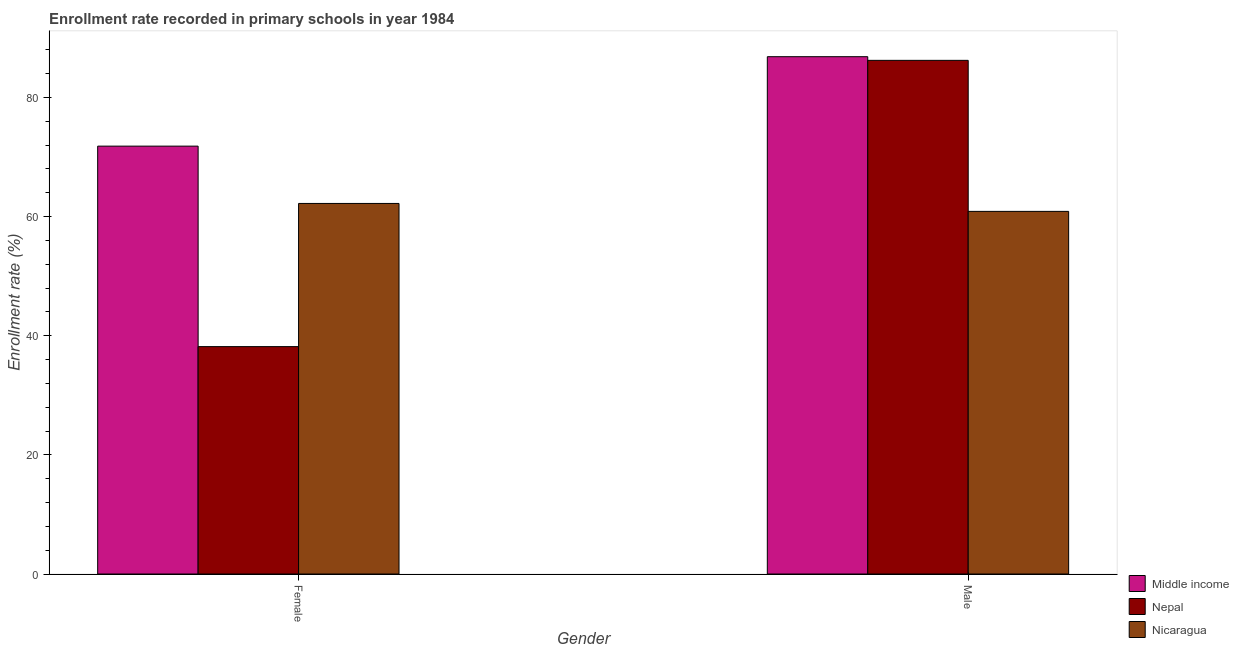How many different coloured bars are there?
Give a very brief answer. 3. Are the number of bars per tick equal to the number of legend labels?
Make the answer very short. Yes. How many bars are there on the 2nd tick from the left?
Offer a terse response. 3. How many bars are there on the 2nd tick from the right?
Provide a short and direct response. 3. What is the label of the 1st group of bars from the left?
Keep it short and to the point. Female. What is the enrollment rate of male students in Nicaragua?
Offer a terse response. 60.88. Across all countries, what is the maximum enrollment rate of female students?
Give a very brief answer. 71.84. Across all countries, what is the minimum enrollment rate of male students?
Provide a short and direct response. 60.88. In which country was the enrollment rate of female students maximum?
Your answer should be compact. Middle income. In which country was the enrollment rate of male students minimum?
Offer a terse response. Nicaragua. What is the total enrollment rate of female students in the graph?
Your response must be concise. 172.23. What is the difference between the enrollment rate of female students in Nepal and that in Nicaragua?
Provide a short and direct response. -24.04. What is the difference between the enrollment rate of male students in Middle income and the enrollment rate of female students in Nepal?
Offer a terse response. 48.68. What is the average enrollment rate of female students per country?
Provide a short and direct response. 57.41. What is the difference between the enrollment rate of female students and enrollment rate of male students in Middle income?
Provide a succinct answer. -15.02. What is the ratio of the enrollment rate of male students in Nepal to that in Nicaragua?
Give a very brief answer. 1.42. In how many countries, is the enrollment rate of male students greater than the average enrollment rate of male students taken over all countries?
Make the answer very short. 2. What does the 1st bar from the left in Female represents?
Keep it short and to the point. Middle income. What does the 2nd bar from the right in Male represents?
Offer a terse response. Nepal. Are all the bars in the graph horizontal?
Ensure brevity in your answer.  No. How many countries are there in the graph?
Make the answer very short. 3. Does the graph contain grids?
Your response must be concise. No. Where does the legend appear in the graph?
Offer a very short reply. Bottom right. What is the title of the graph?
Give a very brief answer. Enrollment rate recorded in primary schools in year 1984. What is the label or title of the X-axis?
Give a very brief answer. Gender. What is the label or title of the Y-axis?
Offer a very short reply. Enrollment rate (%). What is the Enrollment rate (%) in Middle income in Female?
Provide a short and direct response. 71.84. What is the Enrollment rate (%) of Nepal in Female?
Give a very brief answer. 38.18. What is the Enrollment rate (%) of Nicaragua in Female?
Keep it short and to the point. 62.22. What is the Enrollment rate (%) in Middle income in Male?
Your answer should be compact. 86.86. What is the Enrollment rate (%) of Nepal in Male?
Your response must be concise. 86.24. What is the Enrollment rate (%) in Nicaragua in Male?
Ensure brevity in your answer.  60.88. Across all Gender, what is the maximum Enrollment rate (%) in Middle income?
Your response must be concise. 86.86. Across all Gender, what is the maximum Enrollment rate (%) of Nepal?
Provide a succinct answer. 86.24. Across all Gender, what is the maximum Enrollment rate (%) of Nicaragua?
Your answer should be compact. 62.22. Across all Gender, what is the minimum Enrollment rate (%) of Middle income?
Your response must be concise. 71.84. Across all Gender, what is the minimum Enrollment rate (%) of Nepal?
Make the answer very short. 38.18. Across all Gender, what is the minimum Enrollment rate (%) of Nicaragua?
Your answer should be compact. 60.88. What is the total Enrollment rate (%) in Middle income in the graph?
Your answer should be very brief. 158.69. What is the total Enrollment rate (%) in Nepal in the graph?
Give a very brief answer. 124.42. What is the total Enrollment rate (%) of Nicaragua in the graph?
Keep it short and to the point. 123.1. What is the difference between the Enrollment rate (%) in Middle income in Female and that in Male?
Your answer should be compact. -15.02. What is the difference between the Enrollment rate (%) of Nepal in Female and that in Male?
Your answer should be very brief. -48.06. What is the difference between the Enrollment rate (%) in Nicaragua in Female and that in Male?
Your answer should be very brief. 1.33. What is the difference between the Enrollment rate (%) of Middle income in Female and the Enrollment rate (%) of Nepal in Male?
Give a very brief answer. -14.4. What is the difference between the Enrollment rate (%) in Middle income in Female and the Enrollment rate (%) in Nicaragua in Male?
Offer a very short reply. 10.95. What is the difference between the Enrollment rate (%) of Nepal in Female and the Enrollment rate (%) of Nicaragua in Male?
Give a very brief answer. -22.71. What is the average Enrollment rate (%) of Middle income per Gender?
Your answer should be very brief. 79.35. What is the average Enrollment rate (%) in Nepal per Gender?
Offer a very short reply. 62.21. What is the average Enrollment rate (%) in Nicaragua per Gender?
Give a very brief answer. 61.55. What is the difference between the Enrollment rate (%) in Middle income and Enrollment rate (%) in Nepal in Female?
Your answer should be compact. 33.66. What is the difference between the Enrollment rate (%) in Middle income and Enrollment rate (%) in Nicaragua in Female?
Keep it short and to the point. 9.62. What is the difference between the Enrollment rate (%) of Nepal and Enrollment rate (%) of Nicaragua in Female?
Ensure brevity in your answer.  -24.04. What is the difference between the Enrollment rate (%) in Middle income and Enrollment rate (%) in Nepal in Male?
Provide a short and direct response. 0.62. What is the difference between the Enrollment rate (%) in Middle income and Enrollment rate (%) in Nicaragua in Male?
Keep it short and to the point. 25.97. What is the difference between the Enrollment rate (%) in Nepal and Enrollment rate (%) in Nicaragua in Male?
Offer a terse response. 25.36. What is the ratio of the Enrollment rate (%) in Middle income in Female to that in Male?
Offer a very short reply. 0.83. What is the ratio of the Enrollment rate (%) of Nepal in Female to that in Male?
Offer a very short reply. 0.44. What is the ratio of the Enrollment rate (%) in Nicaragua in Female to that in Male?
Offer a very short reply. 1.02. What is the difference between the highest and the second highest Enrollment rate (%) in Middle income?
Offer a very short reply. 15.02. What is the difference between the highest and the second highest Enrollment rate (%) of Nepal?
Keep it short and to the point. 48.06. What is the difference between the highest and the second highest Enrollment rate (%) of Nicaragua?
Give a very brief answer. 1.33. What is the difference between the highest and the lowest Enrollment rate (%) in Middle income?
Ensure brevity in your answer.  15.02. What is the difference between the highest and the lowest Enrollment rate (%) of Nepal?
Your response must be concise. 48.06. What is the difference between the highest and the lowest Enrollment rate (%) in Nicaragua?
Your answer should be compact. 1.33. 